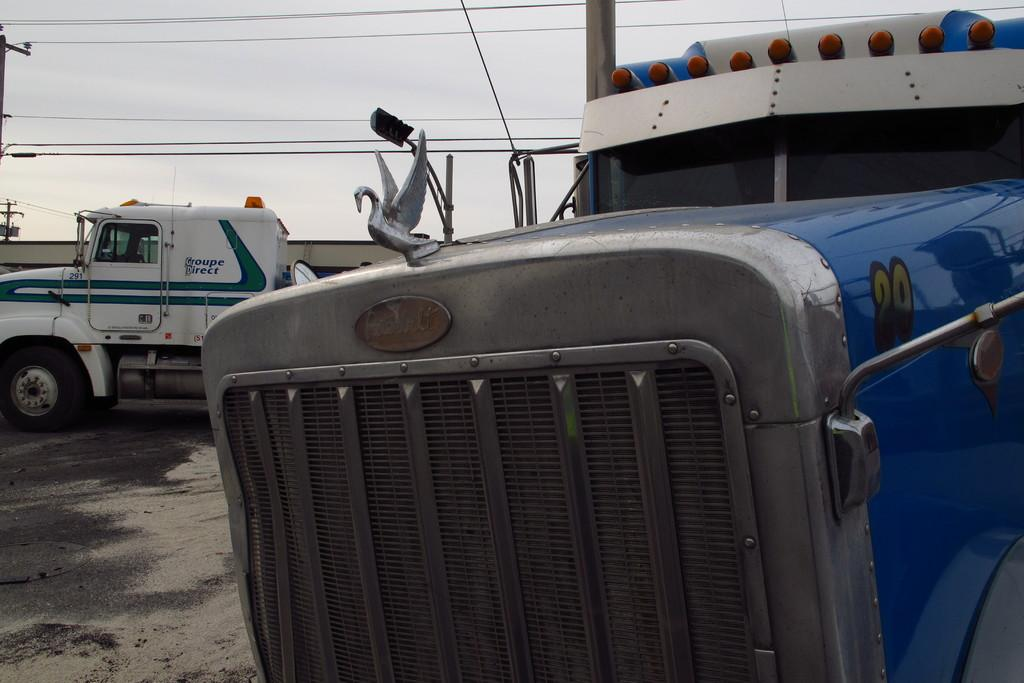What can be seen on the ground in the image? There are vehicles on the ground in the image. What is located on the left side of the image? There are poles on the left side of the image. What are the poles connected to? Wires are attached to the poles. What is visible in the background of the image? The sky is visible in the background of the image. Can you tell me where the father is standing in the image? There is no father present in the image. What type of gate is visible in the image? There is no gate present in the image. 